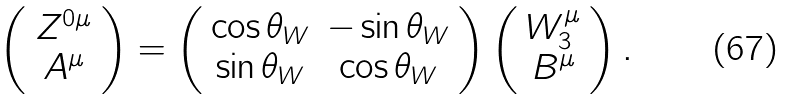<formula> <loc_0><loc_0><loc_500><loc_500>\left ( \begin{array} { c } Z ^ { 0 \mu } \\ A ^ { \mu } \end{array} \right ) = \left ( \begin{array} { c c } \cos \theta _ { W } & - \sin \theta _ { W } \\ \sin \theta _ { W } & \cos \theta _ { W } \end{array} \right ) \left ( \begin{array} { c } W _ { 3 } ^ { \mu } \\ B ^ { \mu } \end{array} \right ) .</formula> 